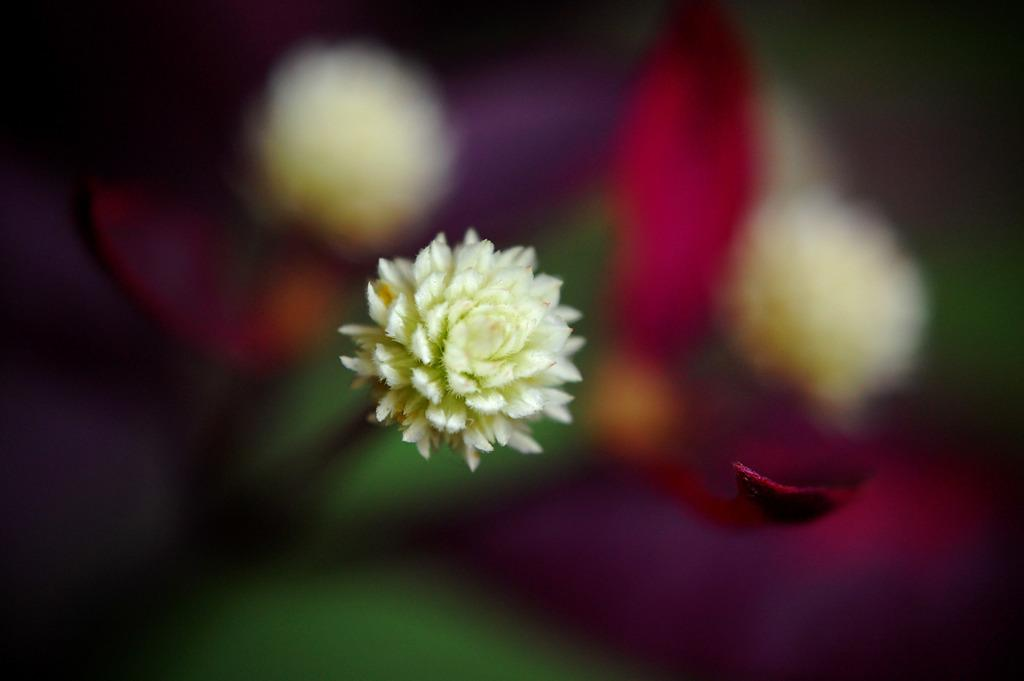What is the main subject in the front of the image? There is a flower in the front of the image. Can you describe the background of the image? The background of the image is blurry. What type of wealth is depicted in the image? There is no depiction of wealth in the image; it features a flower in the front and a blurry background. What type of shade is being used to protect the flower in the image? There is no shade present in the image; it only features a flower in the front and a blurry background. 